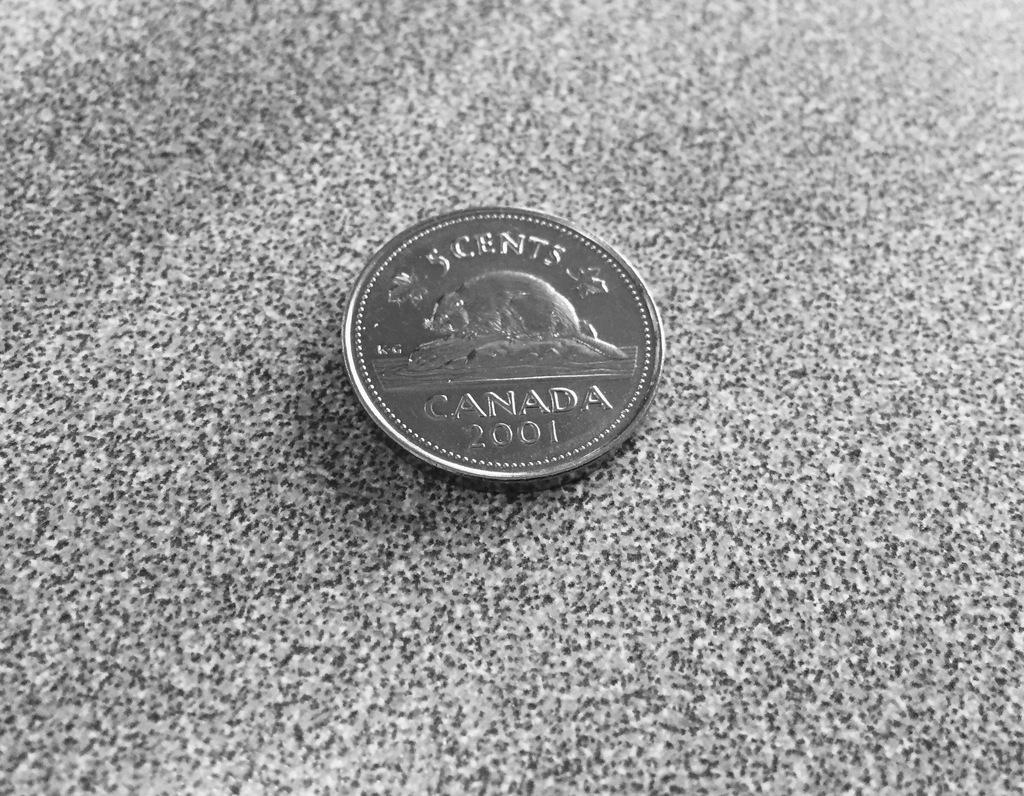<image>
Offer a succinct explanation of the picture presented. The back of a Canadian coin for the value of 5 cents 